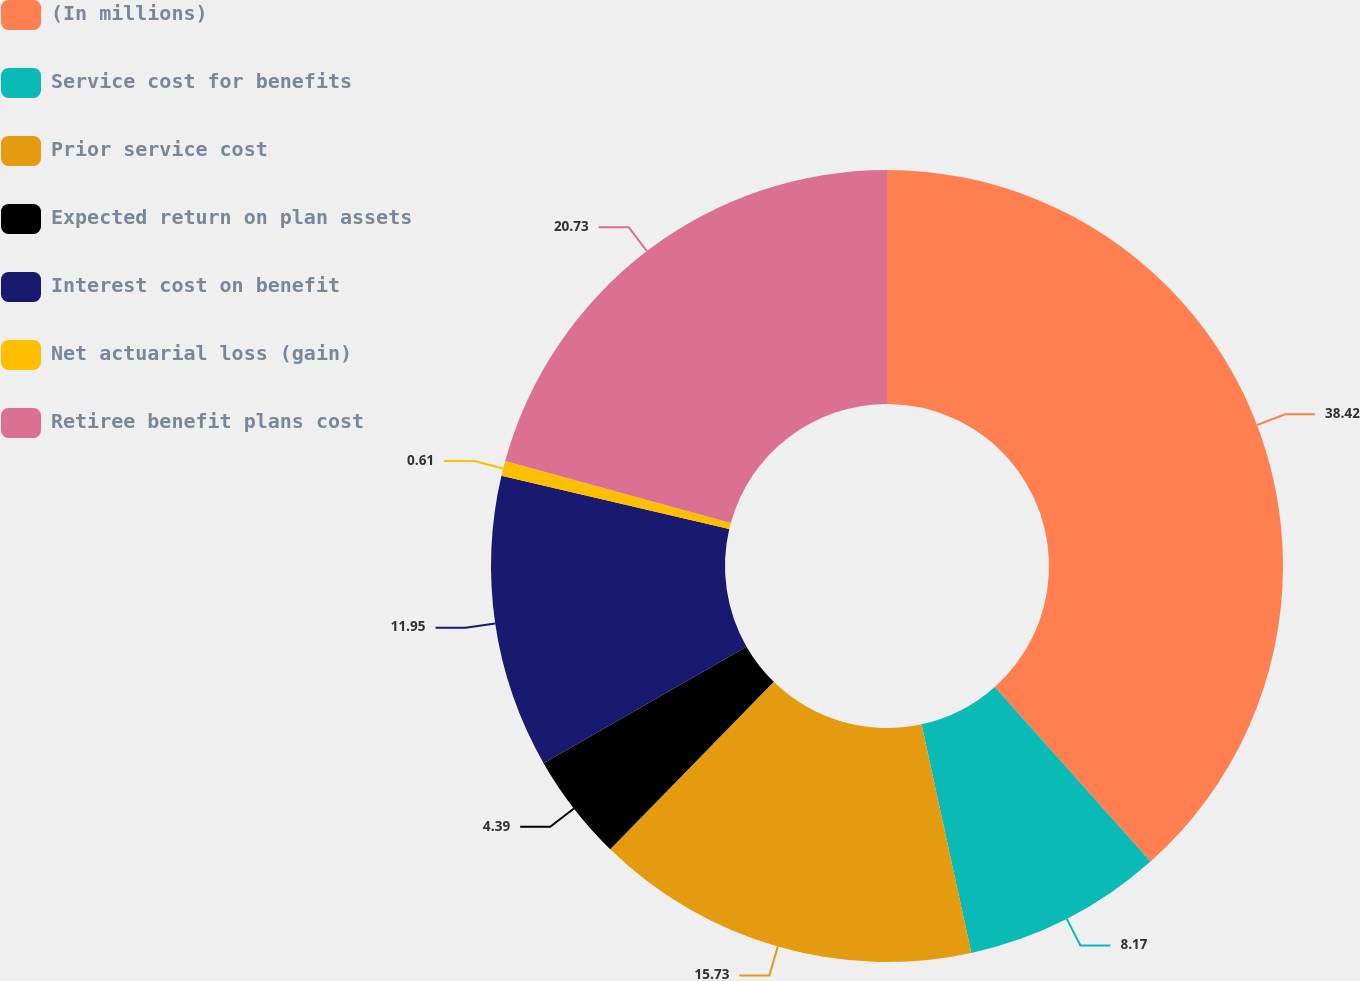Convert chart. <chart><loc_0><loc_0><loc_500><loc_500><pie_chart><fcel>(In millions)<fcel>Service cost for benefits<fcel>Prior service cost<fcel>Expected return on plan assets<fcel>Interest cost on benefit<fcel>Net actuarial loss (gain)<fcel>Retiree benefit plans cost<nl><fcel>38.41%<fcel>8.17%<fcel>15.73%<fcel>4.39%<fcel>11.95%<fcel>0.61%<fcel>20.73%<nl></chart> 